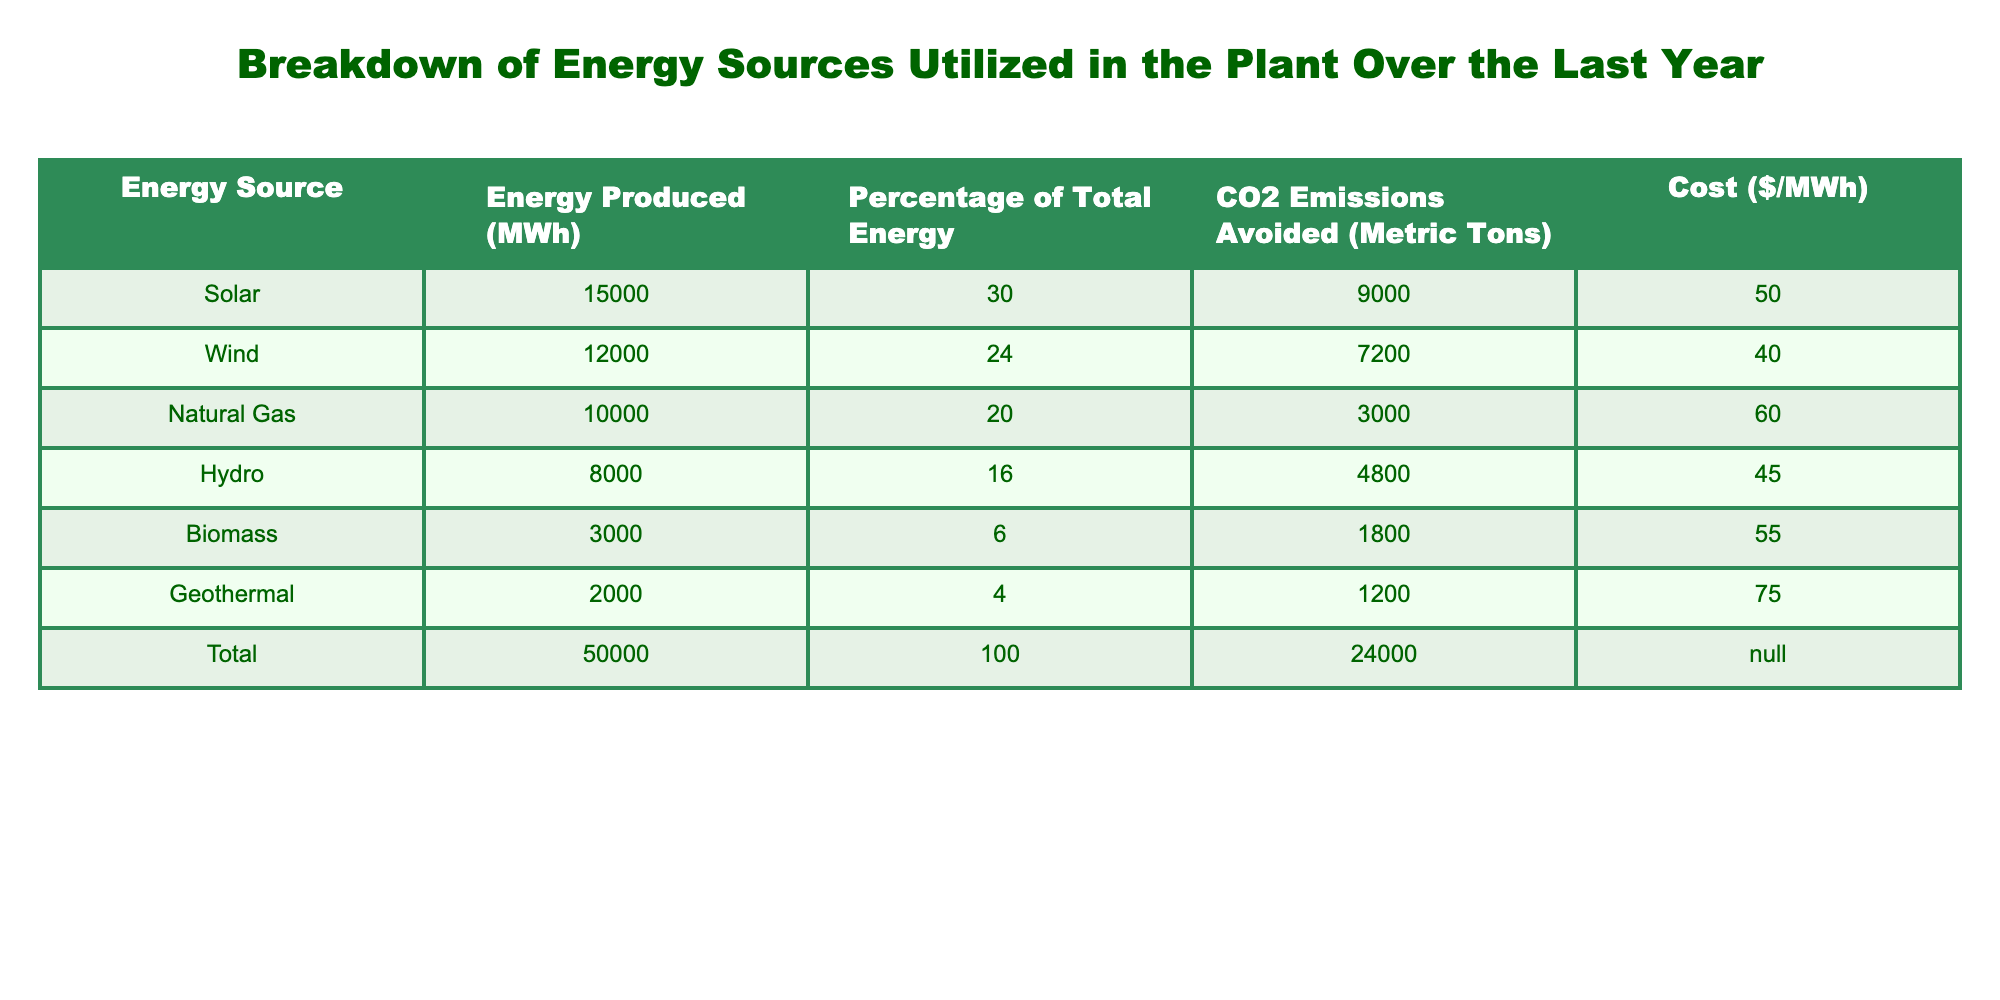What percentage of total energy was produced by wind? The wind energy produced is 12,000 MWh, which accounts for 24% of the total energy production of 50,000 MWh, as noted in the table.
Answer: 24% What is the total CO2 emissions avoided from solar energy? From the table, solar energy has avoided 9,000 metric tons of CO2 emissions.
Answer: 9,000 metric tons Which energy source contributed the least to the total energy production? The biomass energy source produced 3,000 MWh, which is the lowest output when comparing all listed energy sources.
Answer: Biomass What is the average cost per MWh of energy produced from natural gas and geothermal? Natural gas costs $60 per MWh and geothermal costs $75 per MWh. The average is calculated as (60 + 75) / 2 = 67.5.
Answer: $67.50 What is the total amount of CO2 emissions avoided by all energy sources combined? Adding the CO2 emissions avoided from all sources: 9,000 (solar) + 7,200 (wind) + 3,000 (natural gas) + 4,800 (hydro) + 1,800 (biomass) + 1,200 (geothermal) gives a total of 24,000 metric tons.
Answer: 24,000 metric tons Is the percentage contribution of hydro energy greater than that of biomass? Hydro energy contributed 16% while biomass contributed only 6%. Since 16% is greater than 6%, the answer is yes.
Answer: Yes Which energy source produced more energy, solar or wind, and by how much? Solar produced 15,000 MWh and wind produced 12,000 MWh. The difference is calculated as 15,000 - 12,000 = 3,000 MWh.
Answer: Solar by 3,000 MWh If we were to rank the energy sources based on their CO2 emissions avoided, which one ranks highest? The source with the highest CO2 emissions avoided is solar, with 9,000 metric tons. Other sources have lower values when compared.
Answer: Solar How much more energy was produced from natural gas compared to geothermal? Natural gas produced 10,000 MWh while geothermal produced 2,000 MWh. The difference is calculated as 10,000 - 2,000 = 8,000 MWh.
Answer: 8,000 MWh What fraction of the total energy was produced by hydro compared to solar? Hydro produced 8,000 MWh and solar produced 15,000 MWh. The fraction is 8,000 / 15,000 = 0.5333 or approximately 53.33%.
Answer: 53.33% 